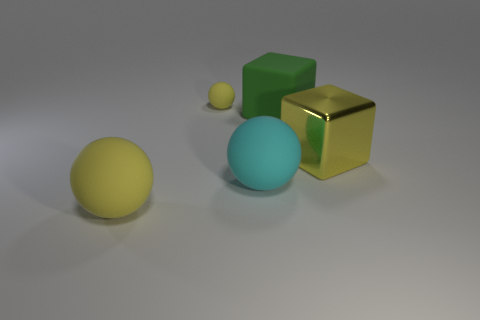Subtract all small balls. How many balls are left? 2 Subtract all cyan balls. How many balls are left? 2 Add 1 yellow objects. How many objects exist? 6 Subtract all purple cylinders. How many yellow spheres are left? 2 Subtract all cyan metal cylinders. Subtract all tiny rubber things. How many objects are left? 4 Add 3 yellow objects. How many yellow objects are left? 6 Add 1 small blue rubber cylinders. How many small blue rubber cylinders exist? 1 Subtract 0 green spheres. How many objects are left? 5 Subtract all blocks. How many objects are left? 3 Subtract 1 blocks. How many blocks are left? 1 